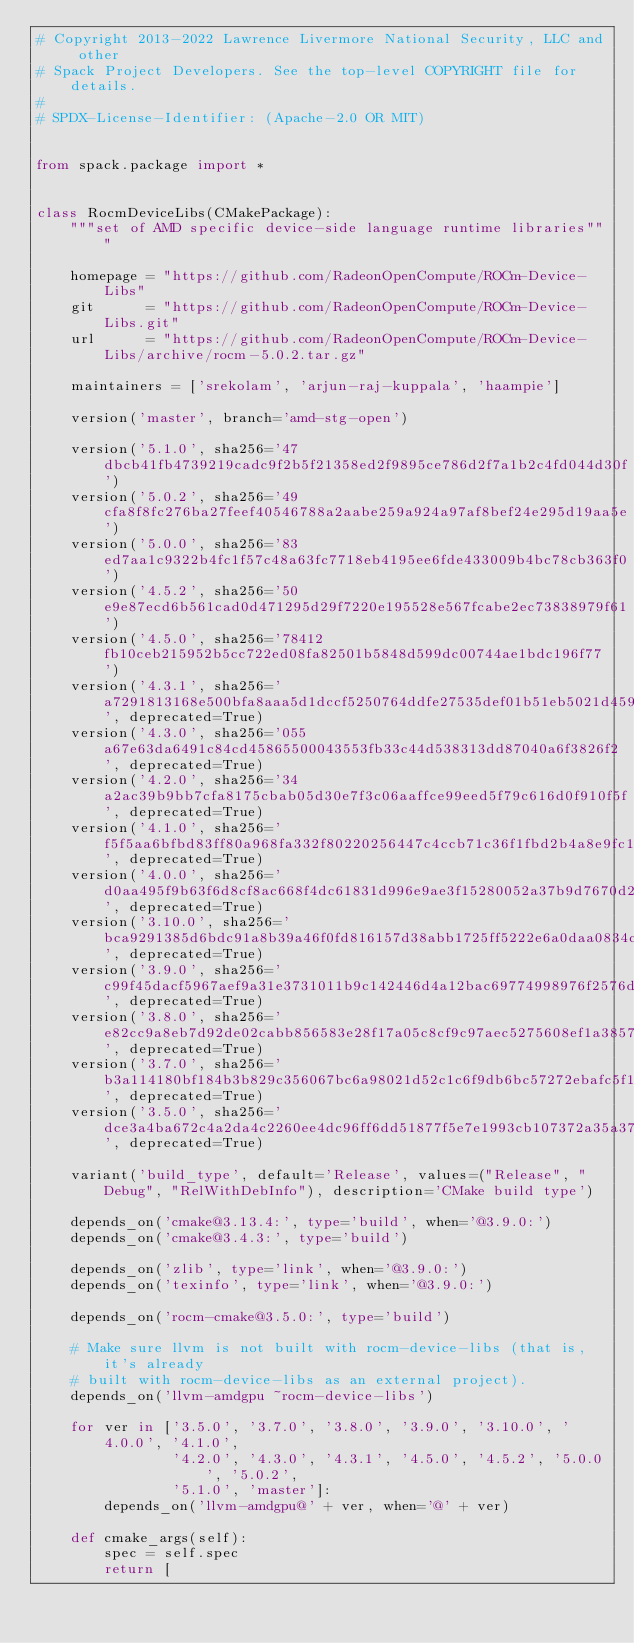<code> <loc_0><loc_0><loc_500><loc_500><_Python_># Copyright 2013-2022 Lawrence Livermore National Security, LLC and other
# Spack Project Developers. See the top-level COPYRIGHT file for details.
#
# SPDX-License-Identifier: (Apache-2.0 OR MIT)


from spack.package import *


class RocmDeviceLibs(CMakePackage):
    """set of AMD specific device-side language runtime libraries"""

    homepage = "https://github.com/RadeonOpenCompute/ROCm-Device-Libs"
    git      = "https://github.com/RadeonOpenCompute/ROCm-Device-Libs.git"
    url      = "https://github.com/RadeonOpenCompute/ROCm-Device-Libs/archive/rocm-5.0.2.tar.gz"

    maintainers = ['srekolam', 'arjun-raj-kuppala', 'haampie']

    version('master', branch='amd-stg-open')

    version('5.1.0', sha256='47dbcb41fb4739219cadc9f2b5f21358ed2f9895ce786d2f7a1b2c4fd044d30f')
    version('5.0.2', sha256='49cfa8f8fc276ba27feef40546788a2aabe259a924a97af8bef24e295d19aa5e')
    version('5.0.0', sha256='83ed7aa1c9322b4fc1f57c48a63fc7718eb4195ee6fde433009b4bc78cb363f0')
    version('4.5.2', sha256='50e9e87ecd6b561cad0d471295d29f7220e195528e567fcabe2ec73838979f61')
    version('4.5.0', sha256='78412fb10ceb215952b5cc722ed08fa82501b5848d599dc00744ae1bdc196f77')
    version('4.3.1', sha256='a7291813168e500bfa8aaa5d1dccf5250764ddfe27535def01b51eb5021d4592', deprecated=True)
    version('4.3.0', sha256='055a67e63da6491c84cd45865500043553fb33c44d538313dd87040a6f3826f2', deprecated=True)
    version('4.2.0', sha256='34a2ac39b9bb7cfa8175cbab05d30e7f3c06aaffce99eed5f79c616d0f910f5f', deprecated=True)
    version('4.1.0', sha256='f5f5aa6bfbd83ff80a968fa332f80220256447c4ccb71c36f1fbd2b4a8e9fc1b', deprecated=True)
    version('4.0.0', sha256='d0aa495f9b63f6d8cf8ac668f4dc61831d996e9ae3f15280052a37b9d7670d2a', deprecated=True)
    version('3.10.0', sha256='bca9291385d6bdc91a8b39a46f0fd816157d38abb1725ff5222e6a0daa0834cc', deprecated=True)
    version('3.9.0', sha256='c99f45dacf5967aef9a31e3731011b9c142446d4a12bac69774998976f2576d7', deprecated=True)
    version('3.8.0', sha256='e82cc9a8eb7d92de02cabb856583e28f17a05c8cf9c97aec5275608ef1a38574', deprecated=True)
    version('3.7.0', sha256='b3a114180bf184b3b829c356067bc6a98021d52c1c6f9db6bc57272ebafc5f1d', deprecated=True)
    version('3.5.0', sha256='dce3a4ba672c4a2da4c2260ee4dc96ff6dd51877f5e7e1993cb107372a35a378', deprecated=True)

    variant('build_type', default='Release', values=("Release", "Debug", "RelWithDebInfo"), description='CMake build type')

    depends_on('cmake@3.13.4:', type='build', when='@3.9.0:')
    depends_on('cmake@3.4.3:', type='build')

    depends_on('zlib', type='link', when='@3.9.0:')
    depends_on('texinfo', type='link', when='@3.9.0:')

    depends_on('rocm-cmake@3.5.0:', type='build')

    # Make sure llvm is not built with rocm-device-libs (that is, it's already
    # built with rocm-device-libs as an external project).
    depends_on('llvm-amdgpu ~rocm-device-libs')

    for ver in ['3.5.0', '3.7.0', '3.8.0', '3.9.0', '3.10.0', '4.0.0', '4.1.0',
                '4.2.0', '4.3.0', '4.3.1', '4.5.0', '4.5.2', '5.0.0', '5.0.2',
                '5.1.0', 'master']:
        depends_on('llvm-amdgpu@' + ver, when='@' + ver)

    def cmake_args(self):
        spec = self.spec
        return [</code> 